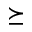<formula> <loc_0><loc_0><loc_500><loc_500>\succeq</formula> 